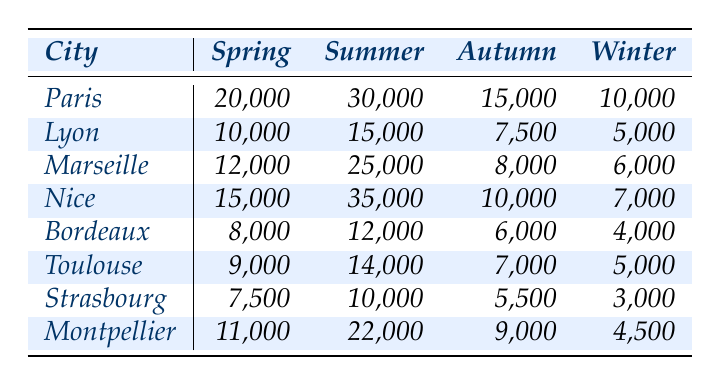What city had the highest number of summer travelers? Looking at the summer column, Nice has the highest value of 35,000, which is greater than the other cities.
Answer: Nice How many travelers visited Lyon in the spring? In the spring column for Lyon, the value is 10,000.
Answer: 10,000 What is the total number of travelers who visited Strasbourg across all seasons? The sum of Strasbourg's values for all seasons is 7,500 (spring) + 10,000 (summer) + 5,500 (autumn) + 3,000 (winter) = 26,000.
Answer: 26,000 Which city saw the lowest number of winter travelers? By comparing the winter values, Bordeaux has the lowest number at 4,000, while other cities have higher figures.
Answer: Bordeaux What is the average number of travelers for Nice throughout the year? The total number of travelers for Nice is 15,000 (spring) + 35,000 (summer) + 10,000 (autumn) + 7,000 (winter) = 67,000. The average is 67,000 / 4 = 16,750.
Answer: 16,750 Did more travelers visit Marseille in summer or in autumn? Marseille had 25,000 travelers in summer and 8,000 in autumn; therefore, summer had more travelers.
Answer: Yes What is the difference in travelers between autumn and winter for Montpellier? The autumn value is 9,000 and the winter value is 4,500. The difference is 9,000 - 4,500 = 4,500.
Answer: 4,500 Which city has a higher total traveler count in spring: Paris or Marseille? Paris had 20,000 travelers in spring, while Marseille had 12,000. Since 20,000 is greater than 12,000, Paris has a higher total.
Answer: Paris What is the total number of travelers for all cities in summer? Summing the summer travelers: 30,000 (Paris) + 15,000 (Lyon) + 25,000 (Marseille) + 35,000 (Nice) + 12,000 (Bordeaux) + 14,000 (Toulouse) + 10,000 (Strasbourg) + 22,000 (Montpellier) gives a total of 171,000.
Answer: 171,000 Is the number of spring travelers higher in Toulouse than in Bordeaux? Toulouse had 9,000 spring travelers and Bordeaux had 8,000; thus, Toulouse's number is higher.
Answer: Yes 